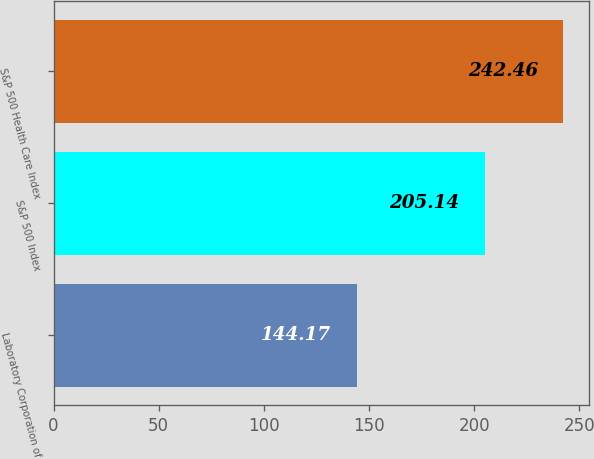Convert chart. <chart><loc_0><loc_0><loc_500><loc_500><bar_chart><fcel>Laboratory Corporation of<fcel>S&P 500 Index<fcel>S&P 500 Health Care Index<nl><fcel>144.17<fcel>205.14<fcel>242.46<nl></chart> 